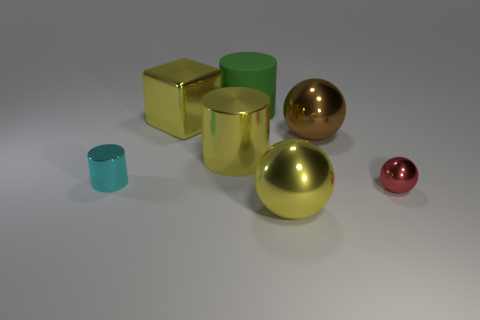Add 1 large yellow metallic cylinders. How many objects exist? 8 Subtract all balls. How many objects are left? 4 Add 1 large yellow metallic blocks. How many large yellow metallic blocks exist? 2 Subtract 0 cyan spheres. How many objects are left? 7 Subtract all gray metallic spheres. Subtract all cyan things. How many objects are left? 6 Add 5 big yellow shiny cylinders. How many big yellow shiny cylinders are left? 6 